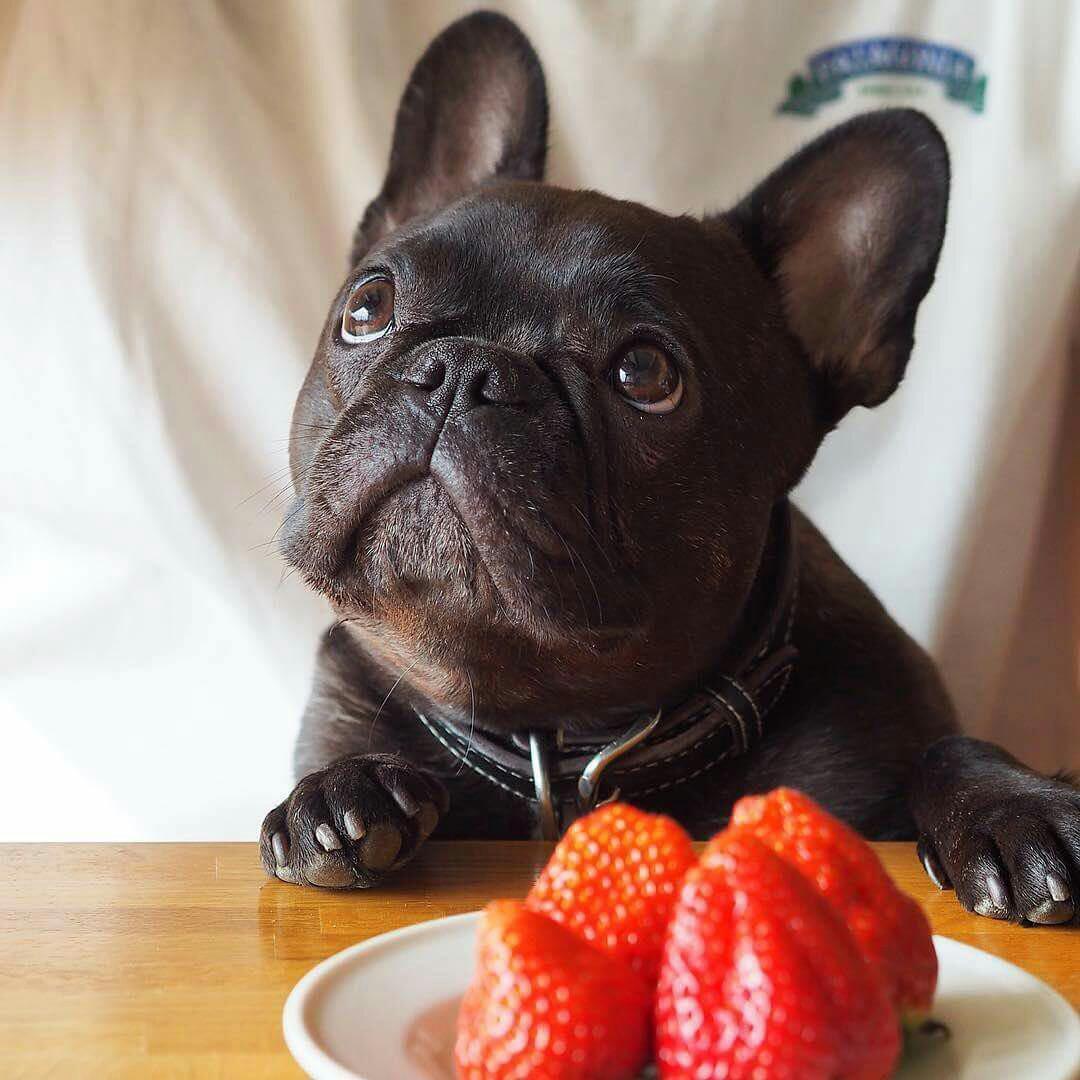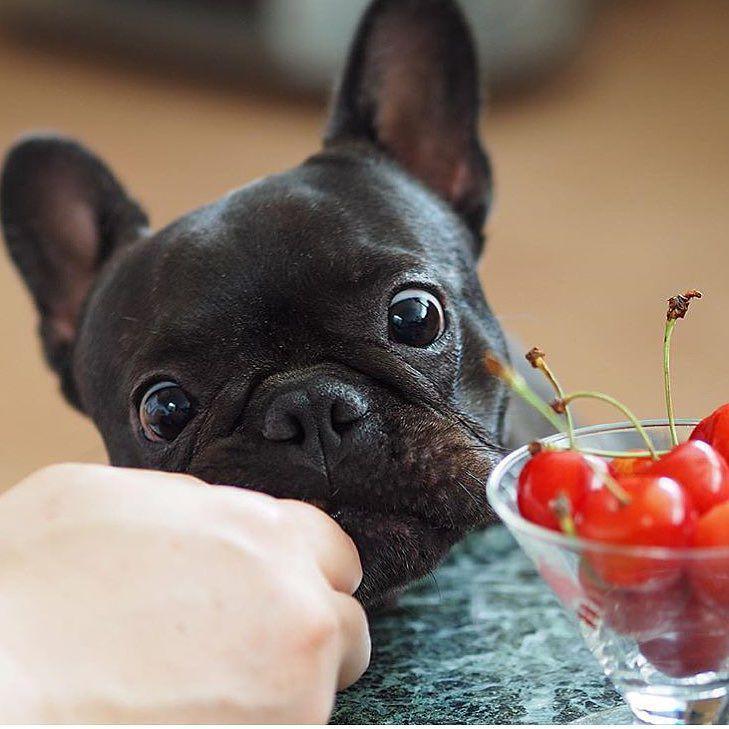The first image is the image on the left, the second image is the image on the right. Given the left and right images, does the statement "Each image contains a french bulldog with brindle fur that is eating, or trying to eat, human food." hold true? Answer yes or no. Yes. The first image is the image on the left, the second image is the image on the right. Examine the images to the left and right. Is the description "A person is feeding a dog by hand." accurate? Answer yes or no. Yes. 